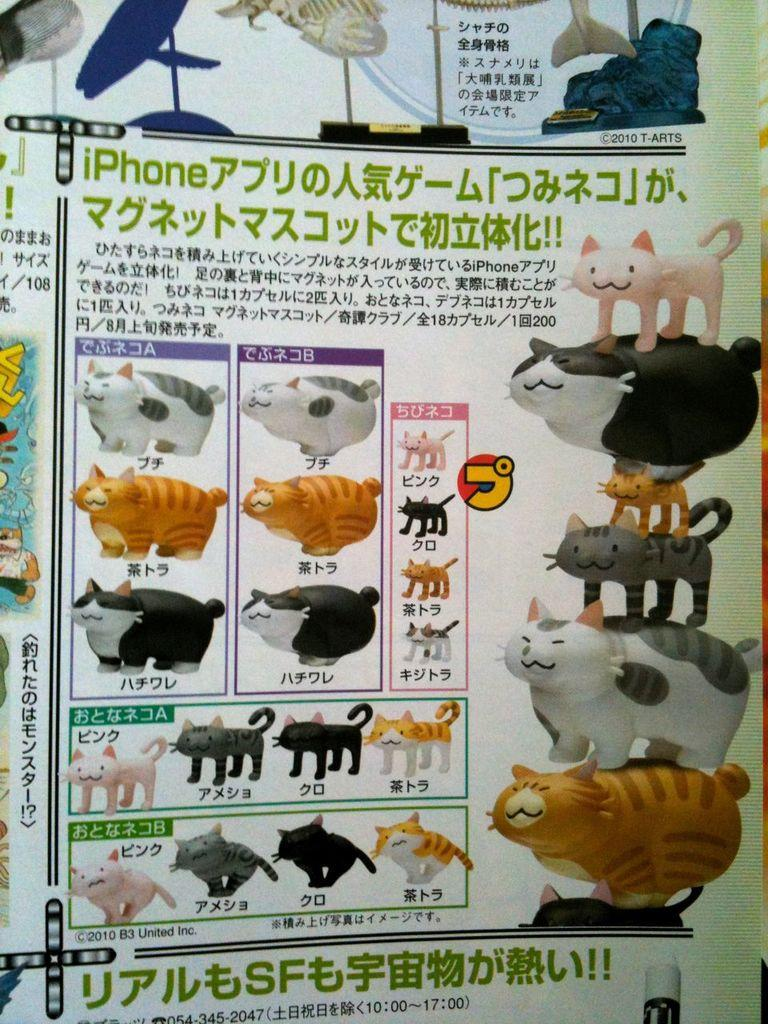What types of living organisms are present in the image? There are animals in the image. How can the animals be distinguished from one another? The animals are in different colors. What is the surface on which the animals are situated? The animals are on a sheet. Is there any text or symbols on the sheet? Yes, there is writing on the sheet. What type of harbor can be seen in the image? There is no harbor present in the image; it features animals on a sheet with writing. Can you describe the plants growing on the street in the image? There are no plants or streets visible in the image. 